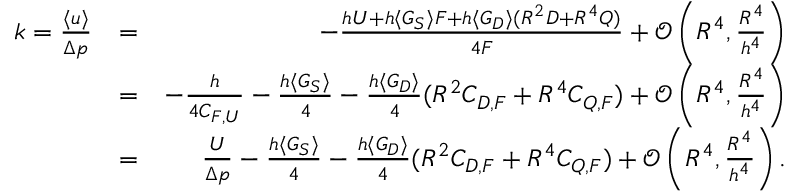<formula> <loc_0><loc_0><loc_500><loc_500>\begin{array} { r l r } { k = \frac { \langle u \rangle } { \Delta p } } & { = } & { - \frac { h U + h \langle G _ { S } \rangle F + h \langle G _ { D } \rangle ( R ^ { 2 } D + R ^ { 4 } Q ) } { 4 F } + \mathcal { O } \left ( R ^ { 4 } , \frac { R ^ { 4 } } { h ^ { 4 } } \right ) } \\ & { = } & { - \frac { h } { 4 C _ { F , U } } - \frac { h \langle G _ { S } \rangle } { 4 } - \frac { h \langle G _ { D } \rangle } { 4 } ( R ^ { 2 } C _ { D , F } + R ^ { 4 } C _ { Q , F } ) + \mathcal { O } \left ( R ^ { 4 } , \frac { R ^ { 4 } } { h ^ { 4 } } \right ) } \\ & { = } & { \frac { U } { \Delta p } - \frac { h \langle G _ { S } \rangle } { 4 } - \frac { h \langle G _ { D } \rangle } { 4 } ( R ^ { 2 } C _ { D , F } + R ^ { 4 } C _ { Q , F } ) + \mathcal { O } \left ( R ^ { 4 } , \frac { R ^ { 4 } } { h ^ { 4 } } \right ) . } \end{array}</formula> 